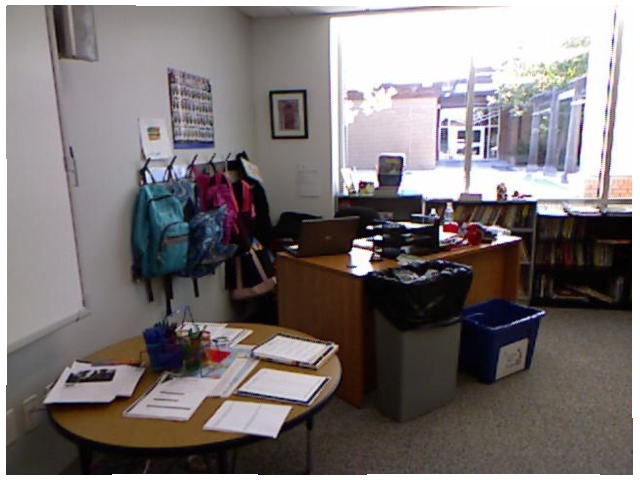<image>
Is the trash can in front of the window? Yes. The trash can is positioned in front of the window, appearing closer to the camera viewpoint. Is there a recycle bin in front of the trash can? No. The recycle bin is not in front of the trash can. The spatial positioning shows a different relationship between these objects. Is the book on the desk? No. The book is not positioned on the desk. They may be near each other, but the book is not supported by or resting on top of the desk. Where is the wall in relation to the backpack? Is it on the backpack? No. The wall is not positioned on the backpack. They may be near each other, but the wall is not supported by or resting on top of the backpack. 